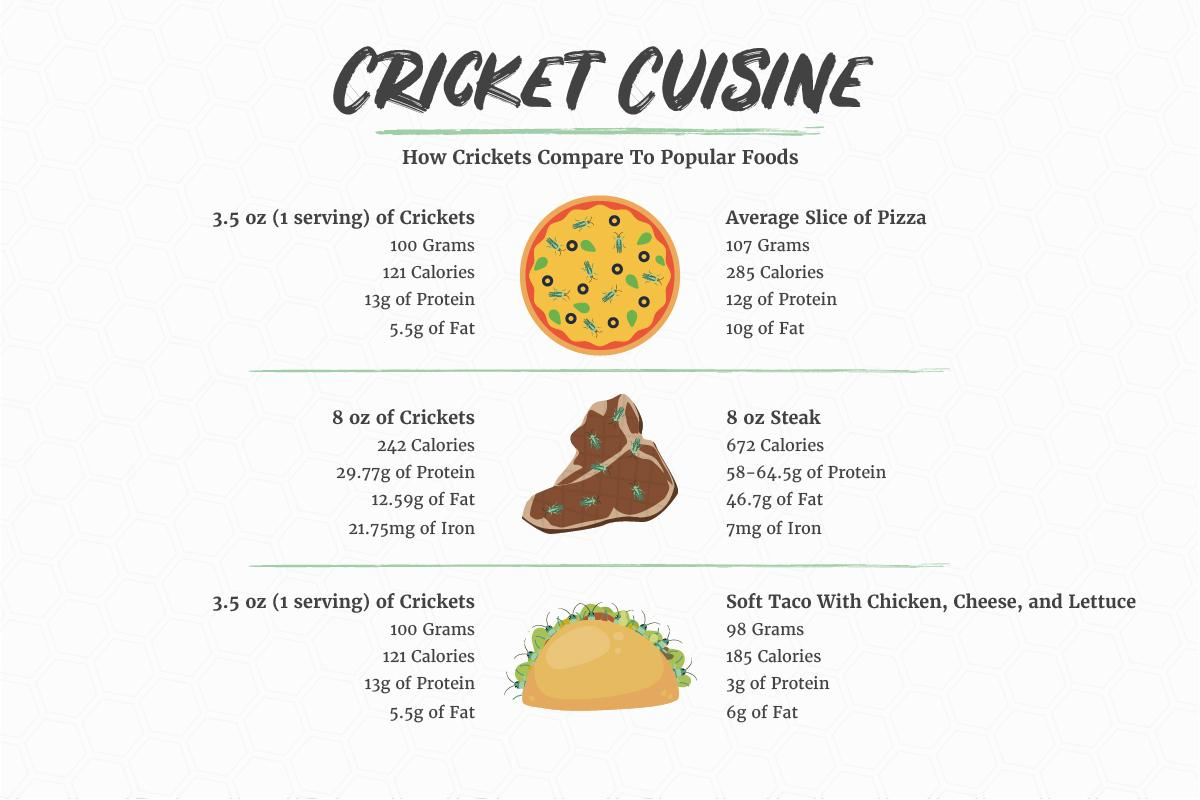Point out several critical features in this image. It is estimated that 8 ounces of crickets and steak combined contain approximately 914 calories. 